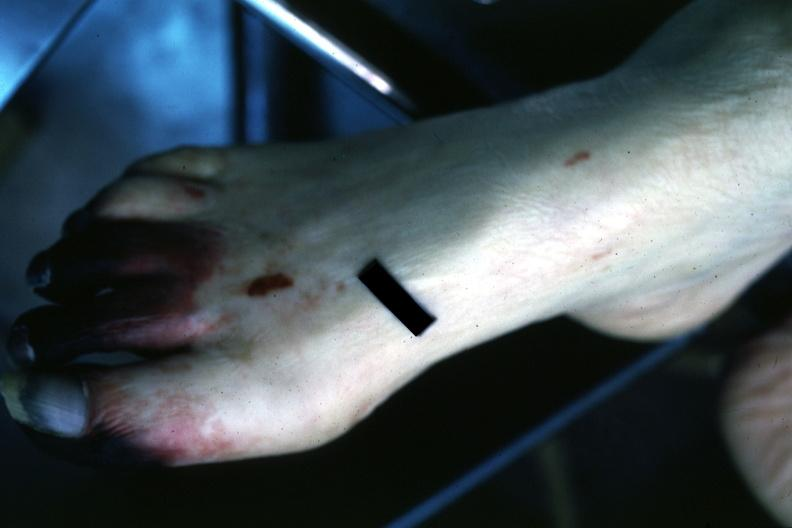how many toes does this image show well gangrenous 1-?
Answer the question using a single word or phrase. 3 